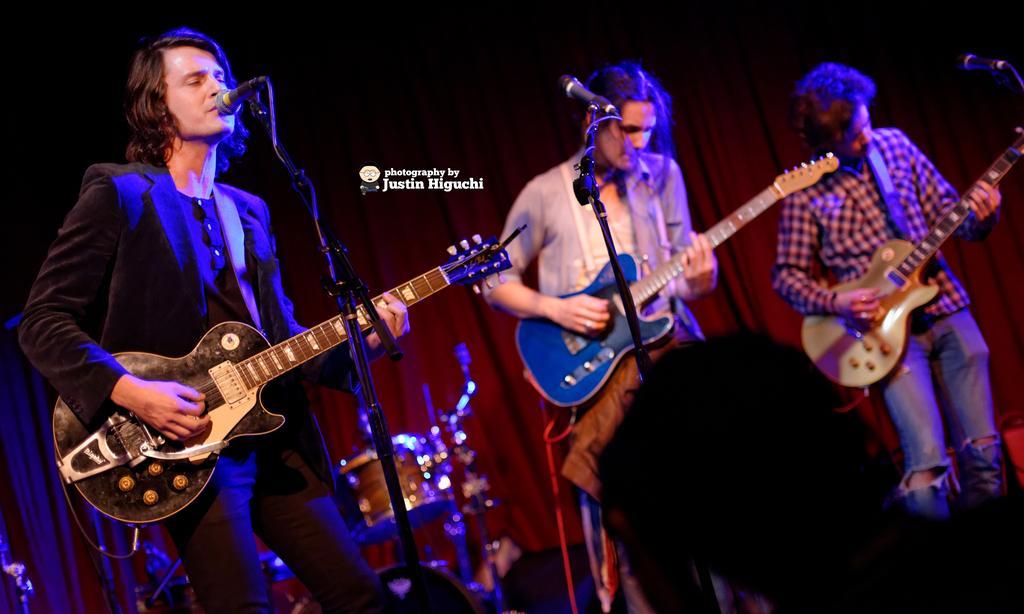How would you summarize this image in a sentence or two? Three person playing guitar, this is microphone and in background there is red color curtain, this is drum. 